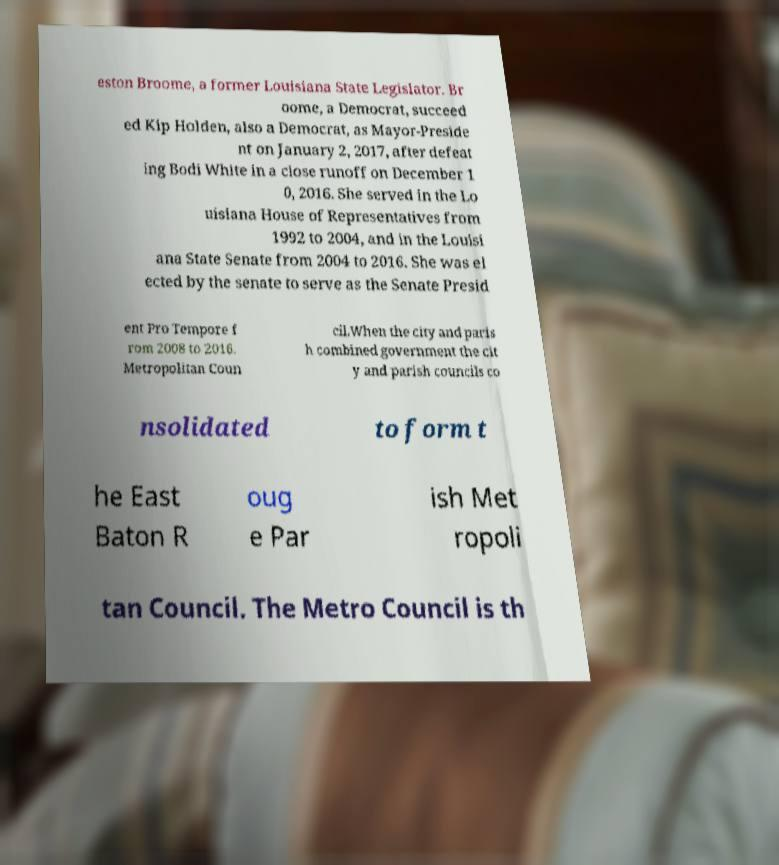Can you read and provide the text displayed in the image?This photo seems to have some interesting text. Can you extract and type it out for me? eston Broome, a former Louisiana State Legislator. Br oome, a Democrat, succeed ed Kip Holden, also a Democrat, as Mayor-Preside nt on January 2, 2017, after defeat ing Bodi White in a close runoff on December 1 0, 2016. She served in the Lo uisiana House of Representatives from 1992 to 2004, and in the Louisi ana State Senate from 2004 to 2016. She was el ected by the senate to serve as the Senate Presid ent Pro Tempore f rom 2008 to 2016. Metropolitan Coun cil.When the city and paris h combined government the cit y and parish councils co nsolidated to form t he East Baton R oug e Par ish Met ropoli tan Council. The Metro Council is th 